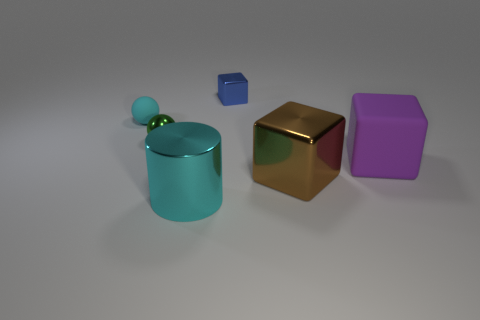How many large green cylinders are the same material as the brown object?
Provide a succinct answer. 0. Are there fewer blue shiny objects than metal things?
Provide a short and direct response. Yes. What is the size of the brown object that is the same shape as the purple matte thing?
Keep it short and to the point. Large. Is the cyan thing that is to the left of the green sphere made of the same material as the large purple thing?
Provide a short and direct response. Yes. Does the large matte thing have the same shape as the big brown thing?
Provide a short and direct response. Yes. What number of objects are tiny shiny objects in front of the blue shiny thing or big purple shiny things?
Your answer should be very brief. 1. The brown cube that is made of the same material as the big cyan cylinder is what size?
Provide a short and direct response. Large. What number of shiny objects have the same color as the tiny metal cube?
Ensure brevity in your answer.  0. How many small objects are purple objects or purple shiny blocks?
Offer a very short reply. 0. What is the size of the rubber ball that is the same color as the cylinder?
Offer a very short reply. Small. 